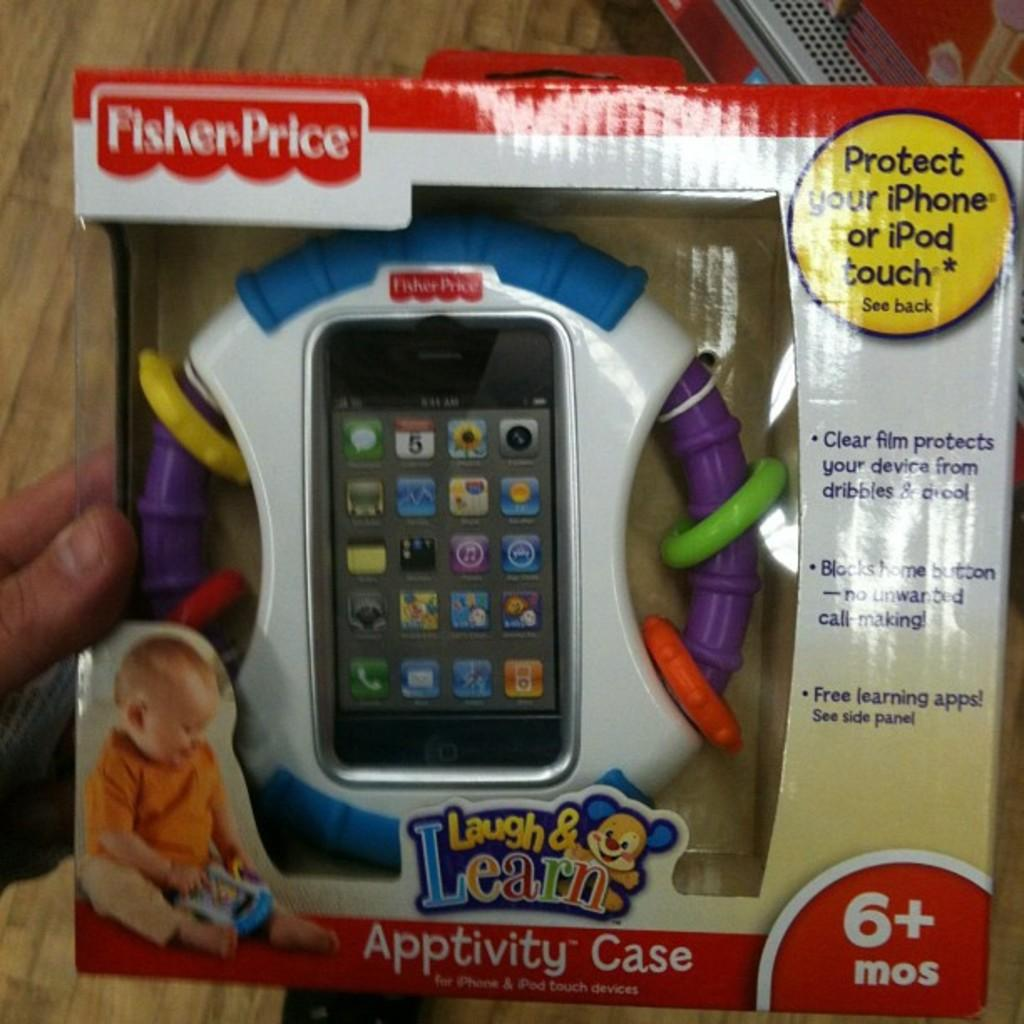<image>
Summarize the visual content of the image. A Laugh & Learn brand "Apptivity Case" for children that protects your iphone or ipod touch. 